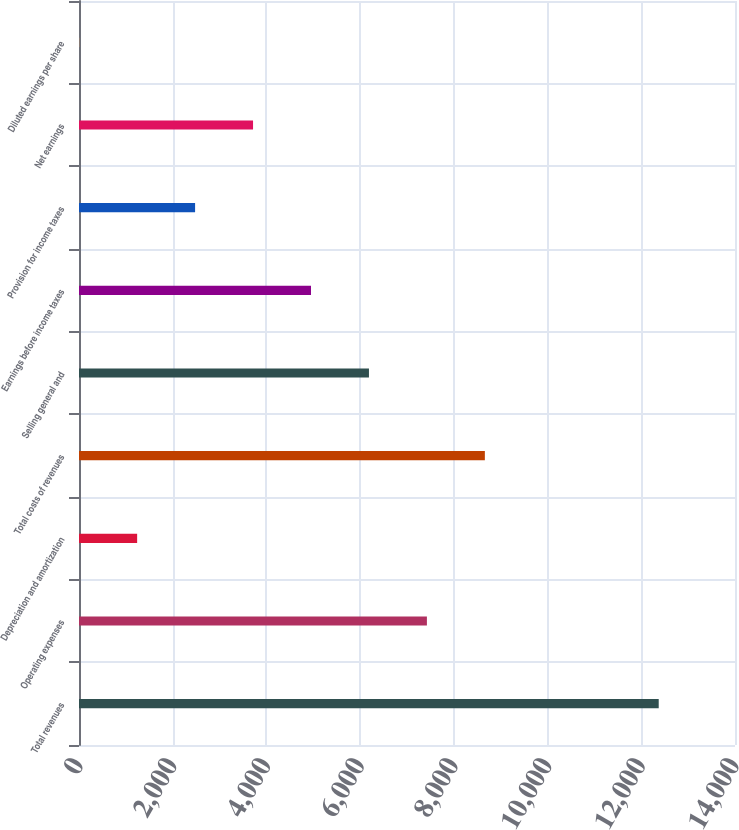Convert chart to OTSL. <chart><loc_0><loc_0><loc_500><loc_500><bar_chart><fcel>Total revenues<fcel>Operating expenses<fcel>Depreciation and amortization<fcel>Total costs of revenues<fcel>Selling general and<fcel>Earnings before income taxes<fcel>Provision for income taxes<fcel>Net earnings<fcel>Diluted earnings per share<nl><fcel>12372<fcel>7424.77<fcel>1240.77<fcel>8661.57<fcel>6187.97<fcel>4951.17<fcel>2477.57<fcel>3714.37<fcel>3.97<nl></chart> 